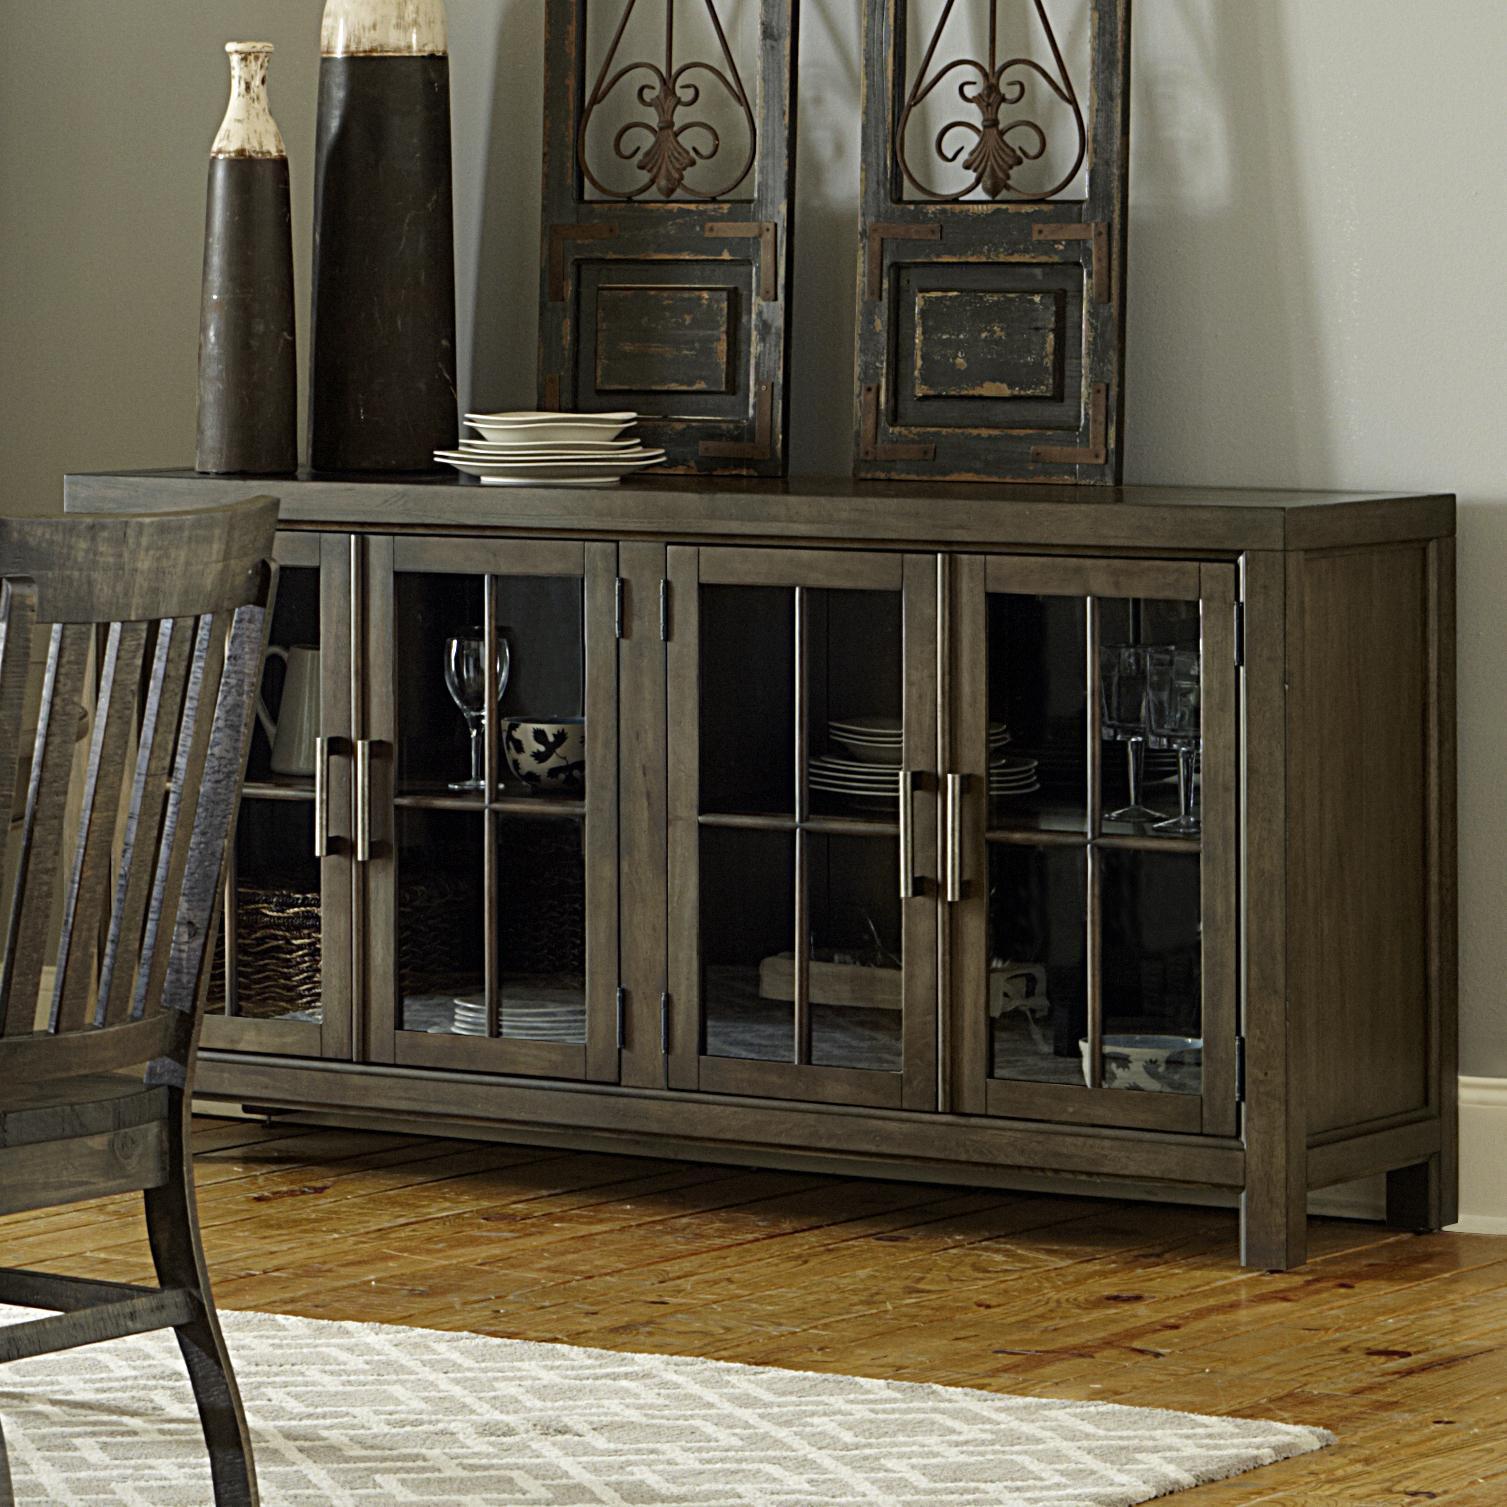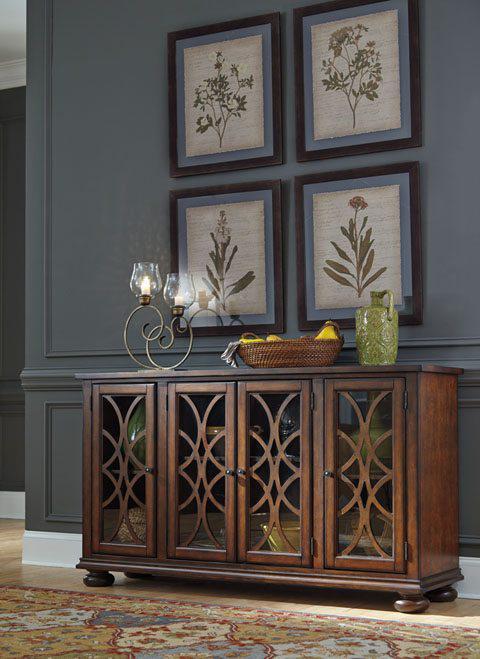The first image is the image on the left, the second image is the image on the right. Given the left and right images, does the statement "There is a combined total of three chairs between the two images." hold true? Answer yes or no. No. The first image is the image on the left, the second image is the image on the right. Examine the images to the left and right. Is the description "There is basket of dark objects atop the china cabinet in the image on the right." accurate? Answer yes or no. No. 